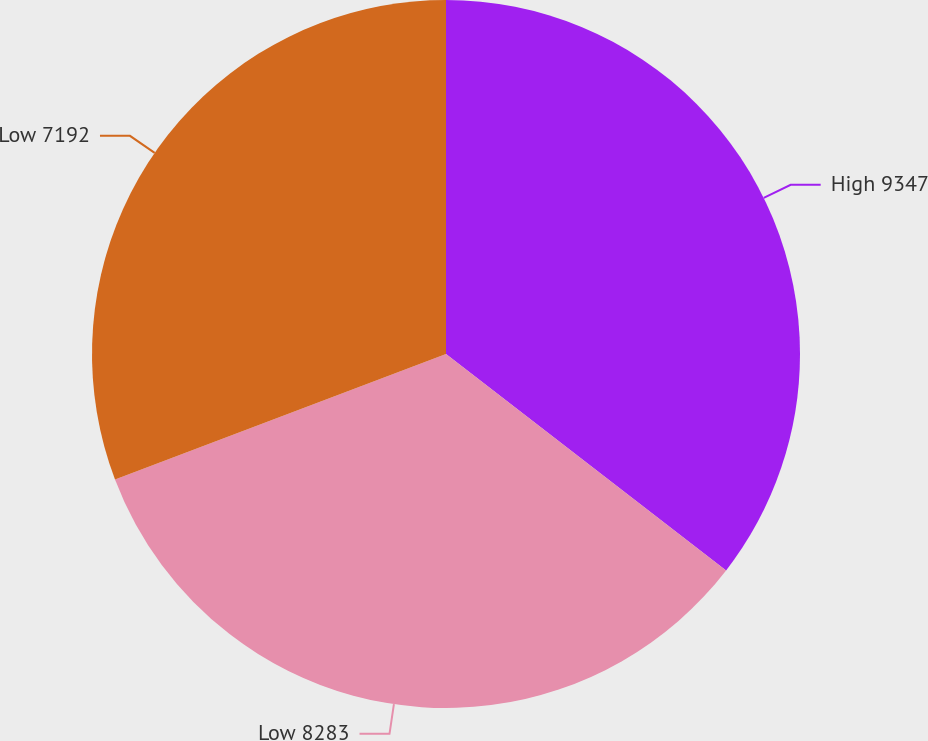<chart> <loc_0><loc_0><loc_500><loc_500><pie_chart><fcel>High 9347<fcel>Low 8283<fcel>Low 7192<nl><fcel>35.47%<fcel>33.76%<fcel>30.77%<nl></chart> 